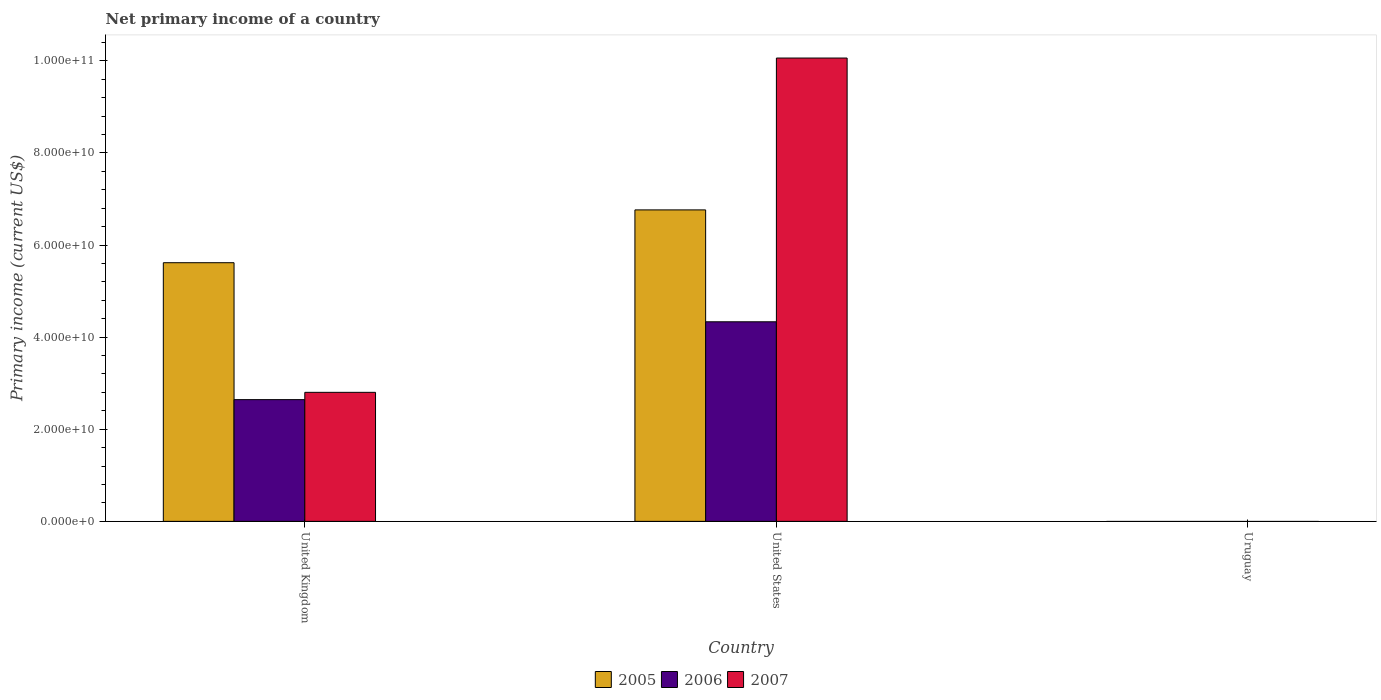How many different coloured bars are there?
Provide a short and direct response. 3. Are the number of bars per tick equal to the number of legend labels?
Keep it short and to the point. No. Are the number of bars on each tick of the X-axis equal?
Provide a short and direct response. No. How many bars are there on the 3rd tick from the left?
Your response must be concise. 0. How many bars are there on the 1st tick from the right?
Keep it short and to the point. 0. What is the label of the 3rd group of bars from the left?
Your answer should be compact. Uruguay. What is the primary income in 2007 in United States?
Offer a terse response. 1.01e+11. Across all countries, what is the maximum primary income in 2007?
Ensure brevity in your answer.  1.01e+11. What is the total primary income in 2007 in the graph?
Provide a succinct answer. 1.29e+11. What is the difference between the primary income in 2007 in United Kingdom and that in United States?
Provide a succinct answer. -7.26e+1. What is the difference between the primary income in 2005 in Uruguay and the primary income in 2006 in United States?
Your response must be concise. -4.33e+1. What is the average primary income in 2005 per country?
Keep it short and to the point. 4.13e+1. What is the difference between the primary income of/in 2005 and primary income of/in 2007 in United States?
Ensure brevity in your answer.  -3.30e+1. What is the ratio of the primary income in 2005 in United Kingdom to that in United States?
Your answer should be compact. 0.83. Is the difference between the primary income in 2005 in United Kingdom and United States greater than the difference between the primary income in 2007 in United Kingdom and United States?
Your answer should be very brief. Yes. What is the difference between the highest and the lowest primary income in 2006?
Offer a very short reply. 4.33e+1. Is it the case that in every country, the sum of the primary income in 2007 and primary income in 2005 is greater than the primary income in 2006?
Offer a terse response. No. How many countries are there in the graph?
Provide a short and direct response. 3. What is the difference between two consecutive major ticks on the Y-axis?
Your answer should be compact. 2.00e+1. Does the graph contain any zero values?
Provide a short and direct response. Yes. Where does the legend appear in the graph?
Keep it short and to the point. Bottom center. What is the title of the graph?
Make the answer very short. Net primary income of a country. Does "2001" appear as one of the legend labels in the graph?
Ensure brevity in your answer.  No. What is the label or title of the Y-axis?
Provide a short and direct response. Primary income (current US$). What is the Primary income (current US$) of 2005 in United Kingdom?
Your answer should be compact. 5.62e+1. What is the Primary income (current US$) in 2006 in United Kingdom?
Offer a very short reply. 2.64e+1. What is the Primary income (current US$) of 2007 in United Kingdom?
Your answer should be very brief. 2.80e+1. What is the Primary income (current US$) in 2005 in United States?
Provide a succinct answer. 6.76e+1. What is the Primary income (current US$) in 2006 in United States?
Keep it short and to the point. 4.33e+1. What is the Primary income (current US$) of 2007 in United States?
Keep it short and to the point. 1.01e+11. What is the Primary income (current US$) in 2006 in Uruguay?
Offer a terse response. 0. What is the Primary income (current US$) in 2007 in Uruguay?
Your answer should be very brief. 0. Across all countries, what is the maximum Primary income (current US$) in 2005?
Your answer should be compact. 6.76e+1. Across all countries, what is the maximum Primary income (current US$) of 2006?
Offer a very short reply. 4.33e+1. Across all countries, what is the maximum Primary income (current US$) in 2007?
Make the answer very short. 1.01e+11. Across all countries, what is the minimum Primary income (current US$) in 2006?
Offer a very short reply. 0. Across all countries, what is the minimum Primary income (current US$) of 2007?
Ensure brevity in your answer.  0. What is the total Primary income (current US$) of 2005 in the graph?
Ensure brevity in your answer.  1.24e+11. What is the total Primary income (current US$) of 2006 in the graph?
Your answer should be compact. 6.98e+1. What is the total Primary income (current US$) in 2007 in the graph?
Make the answer very short. 1.29e+11. What is the difference between the Primary income (current US$) in 2005 in United Kingdom and that in United States?
Ensure brevity in your answer.  -1.15e+1. What is the difference between the Primary income (current US$) in 2006 in United Kingdom and that in United States?
Keep it short and to the point. -1.69e+1. What is the difference between the Primary income (current US$) of 2007 in United Kingdom and that in United States?
Ensure brevity in your answer.  -7.26e+1. What is the difference between the Primary income (current US$) in 2005 in United Kingdom and the Primary income (current US$) in 2006 in United States?
Make the answer very short. 1.28e+1. What is the difference between the Primary income (current US$) of 2005 in United Kingdom and the Primary income (current US$) of 2007 in United States?
Your response must be concise. -4.44e+1. What is the difference between the Primary income (current US$) of 2006 in United Kingdom and the Primary income (current US$) of 2007 in United States?
Offer a very short reply. -7.42e+1. What is the average Primary income (current US$) of 2005 per country?
Ensure brevity in your answer.  4.13e+1. What is the average Primary income (current US$) in 2006 per country?
Offer a very short reply. 2.33e+1. What is the average Primary income (current US$) in 2007 per country?
Offer a very short reply. 4.29e+1. What is the difference between the Primary income (current US$) of 2005 and Primary income (current US$) of 2006 in United Kingdom?
Give a very brief answer. 2.97e+1. What is the difference between the Primary income (current US$) of 2005 and Primary income (current US$) of 2007 in United Kingdom?
Your answer should be compact. 2.81e+1. What is the difference between the Primary income (current US$) in 2006 and Primary income (current US$) in 2007 in United Kingdom?
Offer a terse response. -1.58e+09. What is the difference between the Primary income (current US$) in 2005 and Primary income (current US$) in 2006 in United States?
Your answer should be compact. 2.43e+1. What is the difference between the Primary income (current US$) in 2005 and Primary income (current US$) in 2007 in United States?
Your answer should be very brief. -3.30e+1. What is the difference between the Primary income (current US$) of 2006 and Primary income (current US$) of 2007 in United States?
Your answer should be compact. -5.73e+1. What is the ratio of the Primary income (current US$) of 2005 in United Kingdom to that in United States?
Your response must be concise. 0.83. What is the ratio of the Primary income (current US$) in 2006 in United Kingdom to that in United States?
Keep it short and to the point. 0.61. What is the ratio of the Primary income (current US$) of 2007 in United Kingdom to that in United States?
Make the answer very short. 0.28. What is the difference between the highest and the lowest Primary income (current US$) in 2005?
Offer a terse response. 6.76e+1. What is the difference between the highest and the lowest Primary income (current US$) of 2006?
Make the answer very short. 4.33e+1. What is the difference between the highest and the lowest Primary income (current US$) of 2007?
Ensure brevity in your answer.  1.01e+11. 